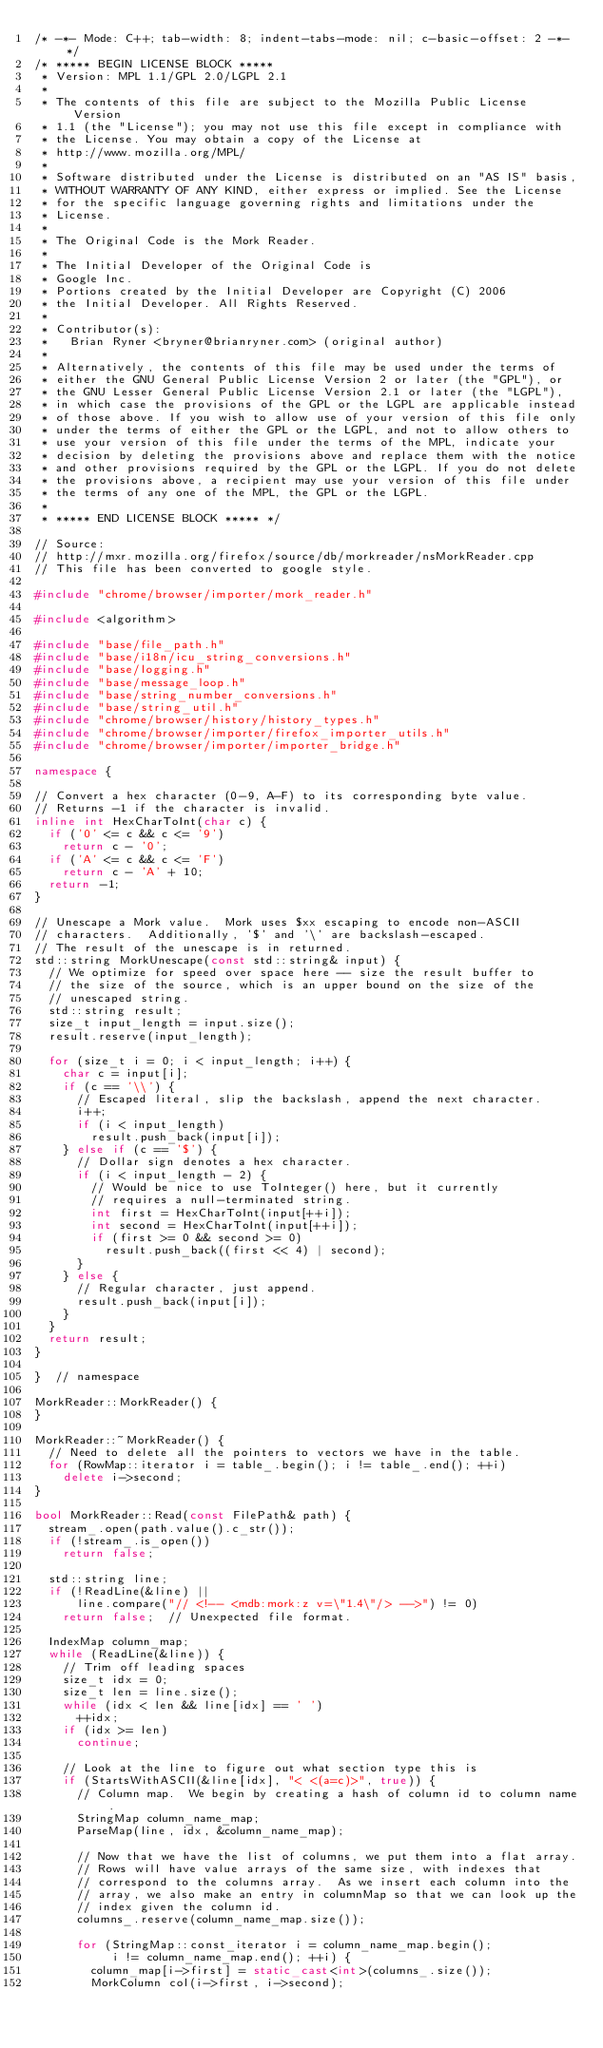Convert code to text. <code><loc_0><loc_0><loc_500><loc_500><_C++_>/* -*- Mode: C++; tab-width: 8; indent-tabs-mode: nil; c-basic-offset: 2 -*- */
/* ***** BEGIN LICENSE BLOCK *****
 * Version: MPL 1.1/GPL 2.0/LGPL 2.1
 *
 * The contents of this file are subject to the Mozilla Public License Version
 * 1.1 (the "License"); you may not use this file except in compliance with
 * the License. You may obtain a copy of the License at
 * http://www.mozilla.org/MPL/
 *
 * Software distributed under the License is distributed on an "AS IS" basis,
 * WITHOUT WARRANTY OF ANY KIND, either express or implied. See the License
 * for the specific language governing rights and limitations under the
 * License.
 *
 * The Original Code is the Mork Reader.
 *
 * The Initial Developer of the Original Code is
 * Google Inc.
 * Portions created by the Initial Developer are Copyright (C) 2006
 * the Initial Developer. All Rights Reserved.
 *
 * Contributor(s):
 *   Brian Ryner <bryner@brianryner.com> (original author)
 *
 * Alternatively, the contents of this file may be used under the terms of
 * either the GNU General Public License Version 2 or later (the "GPL"), or
 * the GNU Lesser General Public License Version 2.1 or later (the "LGPL"),
 * in which case the provisions of the GPL or the LGPL are applicable instead
 * of those above. If you wish to allow use of your version of this file only
 * under the terms of either the GPL or the LGPL, and not to allow others to
 * use your version of this file under the terms of the MPL, indicate your
 * decision by deleting the provisions above and replace them with the notice
 * and other provisions required by the GPL or the LGPL. If you do not delete
 * the provisions above, a recipient may use your version of this file under
 * the terms of any one of the MPL, the GPL or the LGPL.
 *
 * ***** END LICENSE BLOCK ***** */

// Source:
// http://mxr.mozilla.org/firefox/source/db/morkreader/nsMorkReader.cpp
// This file has been converted to google style.

#include "chrome/browser/importer/mork_reader.h"

#include <algorithm>

#include "base/file_path.h"
#include "base/i18n/icu_string_conversions.h"
#include "base/logging.h"
#include "base/message_loop.h"
#include "base/string_number_conversions.h"
#include "base/string_util.h"
#include "chrome/browser/history/history_types.h"
#include "chrome/browser/importer/firefox_importer_utils.h"
#include "chrome/browser/importer/importer_bridge.h"

namespace {

// Convert a hex character (0-9, A-F) to its corresponding byte value.
// Returns -1 if the character is invalid.
inline int HexCharToInt(char c) {
  if ('0' <= c && c <= '9')
    return c - '0';
  if ('A' <= c && c <= 'F')
    return c - 'A' + 10;
  return -1;
}

// Unescape a Mork value.  Mork uses $xx escaping to encode non-ASCII
// characters.  Additionally, '$' and '\' are backslash-escaped.
// The result of the unescape is in returned.
std::string MorkUnescape(const std::string& input) {
  // We optimize for speed over space here -- size the result buffer to
  // the size of the source, which is an upper bound on the size of the
  // unescaped string.
  std::string result;
  size_t input_length = input.size();
  result.reserve(input_length);

  for (size_t i = 0; i < input_length; i++) {
    char c = input[i];
    if (c == '\\') {
      // Escaped literal, slip the backslash, append the next character.
      i++;
      if (i < input_length)
        result.push_back(input[i]);
    } else if (c == '$') {
      // Dollar sign denotes a hex character.
      if (i < input_length - 2) {
        // Would be nice to use ToInteger() here, but it currently
        // requires a null-terminated string.
        int first = HexCharToInt(input[++i]);
        int second = HexCharToInt(input[++i]);
        if (first >= 0 && second >= 0)
          result.push_back((first << 4) | second);
      }
    } else {
      // Regular character, just append.
      result.push_back(input[i]);
    }
  }
  return result;
}

}  // namespace

MorkReader::MorkReader() {
}

MorkReader::~MorkReader() {
  // Need to delete all the pointers to vectors we have in the table.
  for (RowMap::iterator i = table_.begin(); i != table_.end(); ++i)
    delete i->second;
}

bool MorkReader::Read(const FilePath& path) {
  stream_.open(path.value().c_str());
  if (!stream_.is_open())
    return false;

  std::string line;
  if (!ReadLine(&line) ||
      line.compare("// <!-- <mdb:mork:z v=\"1.4\"/> -->") != 0)
    return false;  // Unexpected file format.

  IndexMap column_map;
  while (ReadLine(&line)) {
    // Trim off leading spaces
    size_t idx = 0;
    size_t len = line.size();
    while (idx < len && line[idx] == ' ')
      ++idx;
    if (idx >= len)
      continue;

    // Look at the line to figure out what section type this is
    if (StartsWithASCII(&line[idx], "< <(a=c)>", true)) {
      // Column map.  We begin by creating a hash of column id to column name.
      StringMap column_name_map;
      ParseMap(line, idx, &column_name_map);

      // Now that we have the list of columns, we put them into a flat array.
      // Rows will have value arrays of the same size, with indexes that
      // correspond to the columns array.  As we insert each column into the
      // array, we also make an entry in columnMap so that we can look up the
      // index given the column id.
      columns_.reserve(column_name_map.size());

      for (StringMap::const_iterator i = column_name_map.begin();
           i != column_name_map.end(); ++i) {
        column_map[i->first] = static_cast<int>(columns_.size());
        MorkColumn col(i->first, i->second);</code> 